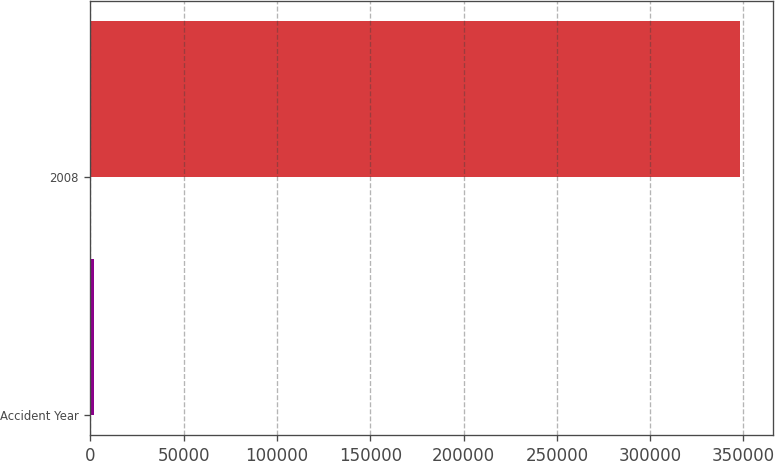Convert chart to OTSL. <chart><loc_0><loc_0><loc_500><loc_500><bar_chart><fcel>Accident Year<fcel>2008<nl><fcel>2011<fcel>348162<nl></chart> 